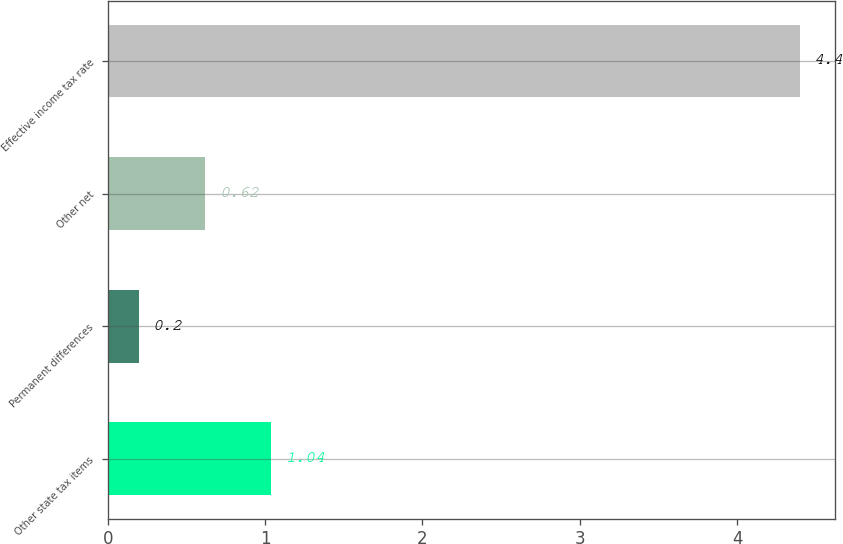Convert chart to OTSL. <chart><loc_0><loc_0><loc_500><loc_500><bar_chart><fcel>Other state tax items<fcel>Permanent differences<fcel>Other net<fcel>Effective income tax rate<nl><fcel>1.04<fcel>0.2<fcel>0.62<fcel>4.4<nl></chart> 